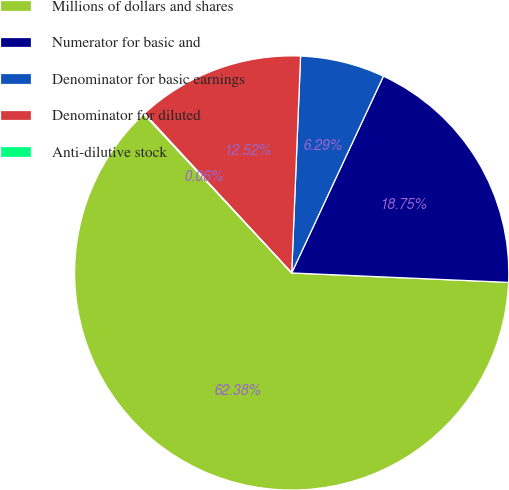Convert chart. <chart><loc_0><loc_0><loc_500><loc_500><pie_chart><fcel>Millions of dollars and shares<fcel>Numerator for basic and<fcel>Denominator for basic earnings<fcel>Denominator for diluted<fcel>Anti-dilutive stock<nl><fcel>62.38%<fcel>18.75%<fcel>6.29%<fcel>12.52%<fcel>0.06%<nl></chart> 